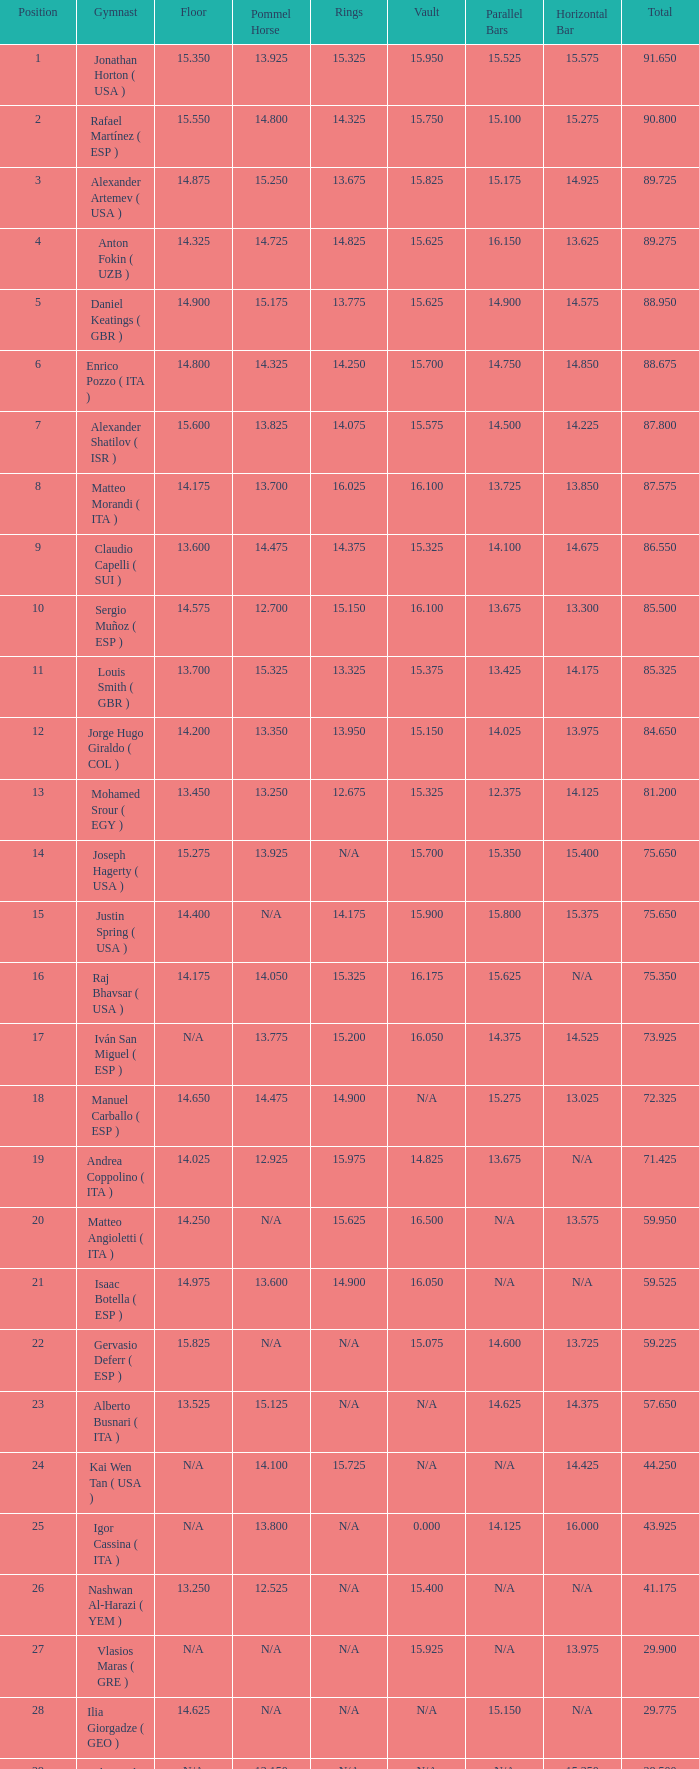If the floor has a number of 14.200, what would be the number assigned to the parallel bars? 14.025. 